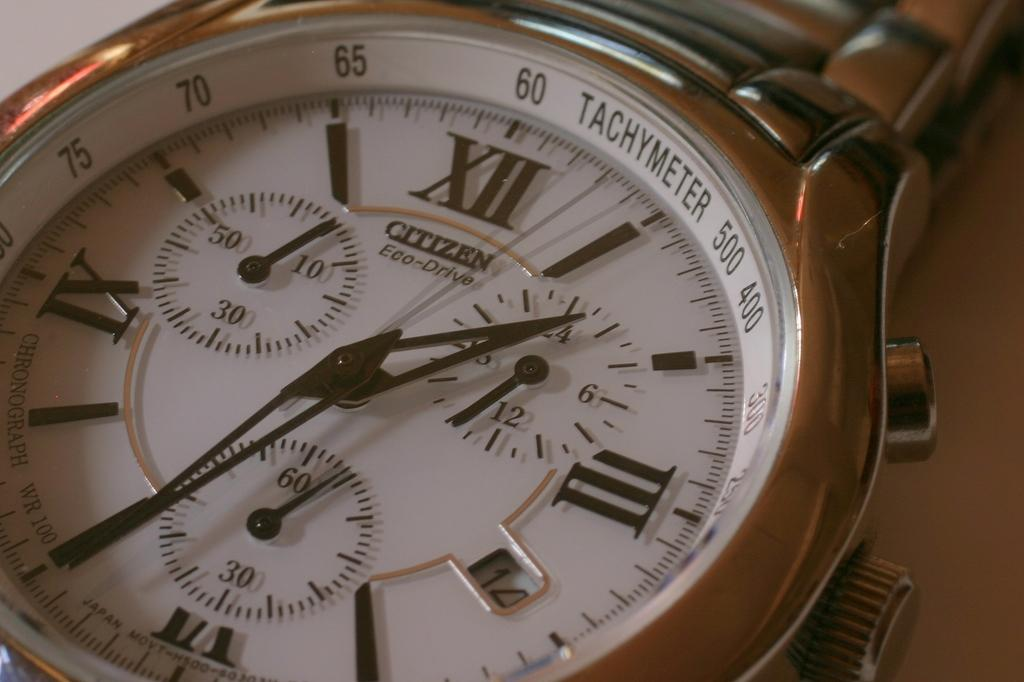<image>
Relay a brief, clear account of the picture shown. the citizen watch has a tachymeter shown on it 